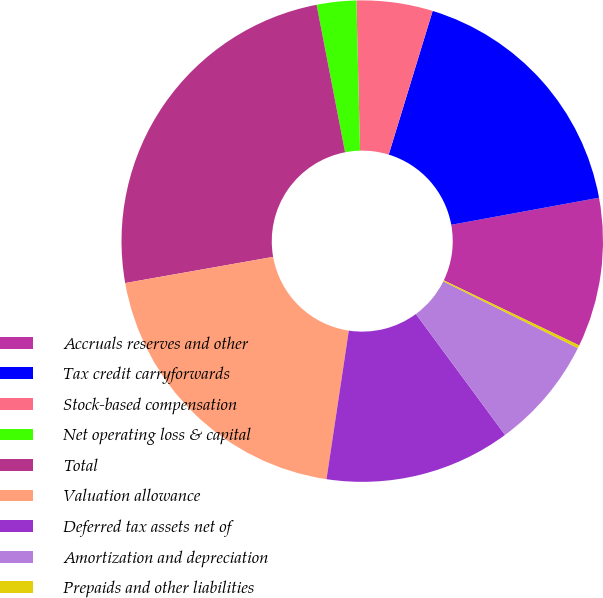<chart> <loc_0><loc_0><loc_500><loc_500><pie_chart><fcel>Accruals reserves and other<fcel>Tax credit carryforwards<fcel>Stock-based compensation<fcel>Net operating loss & capital<fcel>Total<fcel>Valuation allowance<fcel>Deferred tax assets net of<fcel>Amortization and depreciation<fcel>Prepaids and other liabilities<nl><fcel>10.02%<fcel>17.39%<fcel>5.11%<fcel>2.65%<fcel>24.75%<fcel>19.84%<fcel>12.48%<fcel>7.56%<fcel>0.2%<nl></chart> 